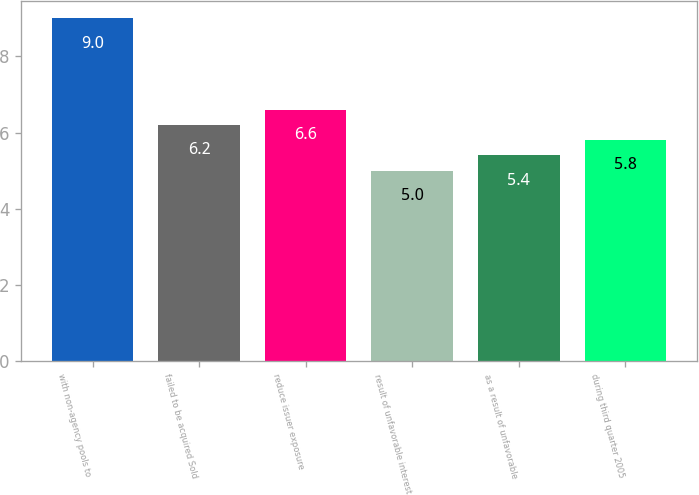<chart> <loc_0><loc_0><loc_500><loc_500><bar_chart><fcel>with non-agency pools to<fcel>failed to be acquired Sold<fcel>reduce issuer exposure<fcel>result of unfavorable interest<fcel>as a result of unfavorable<fcel>during third quarter 2005<nl><fcel>9<fcel>6.2<fcel>6.6<fcel>5<fcel>5.4<fcel>5.8<nl></chart> 